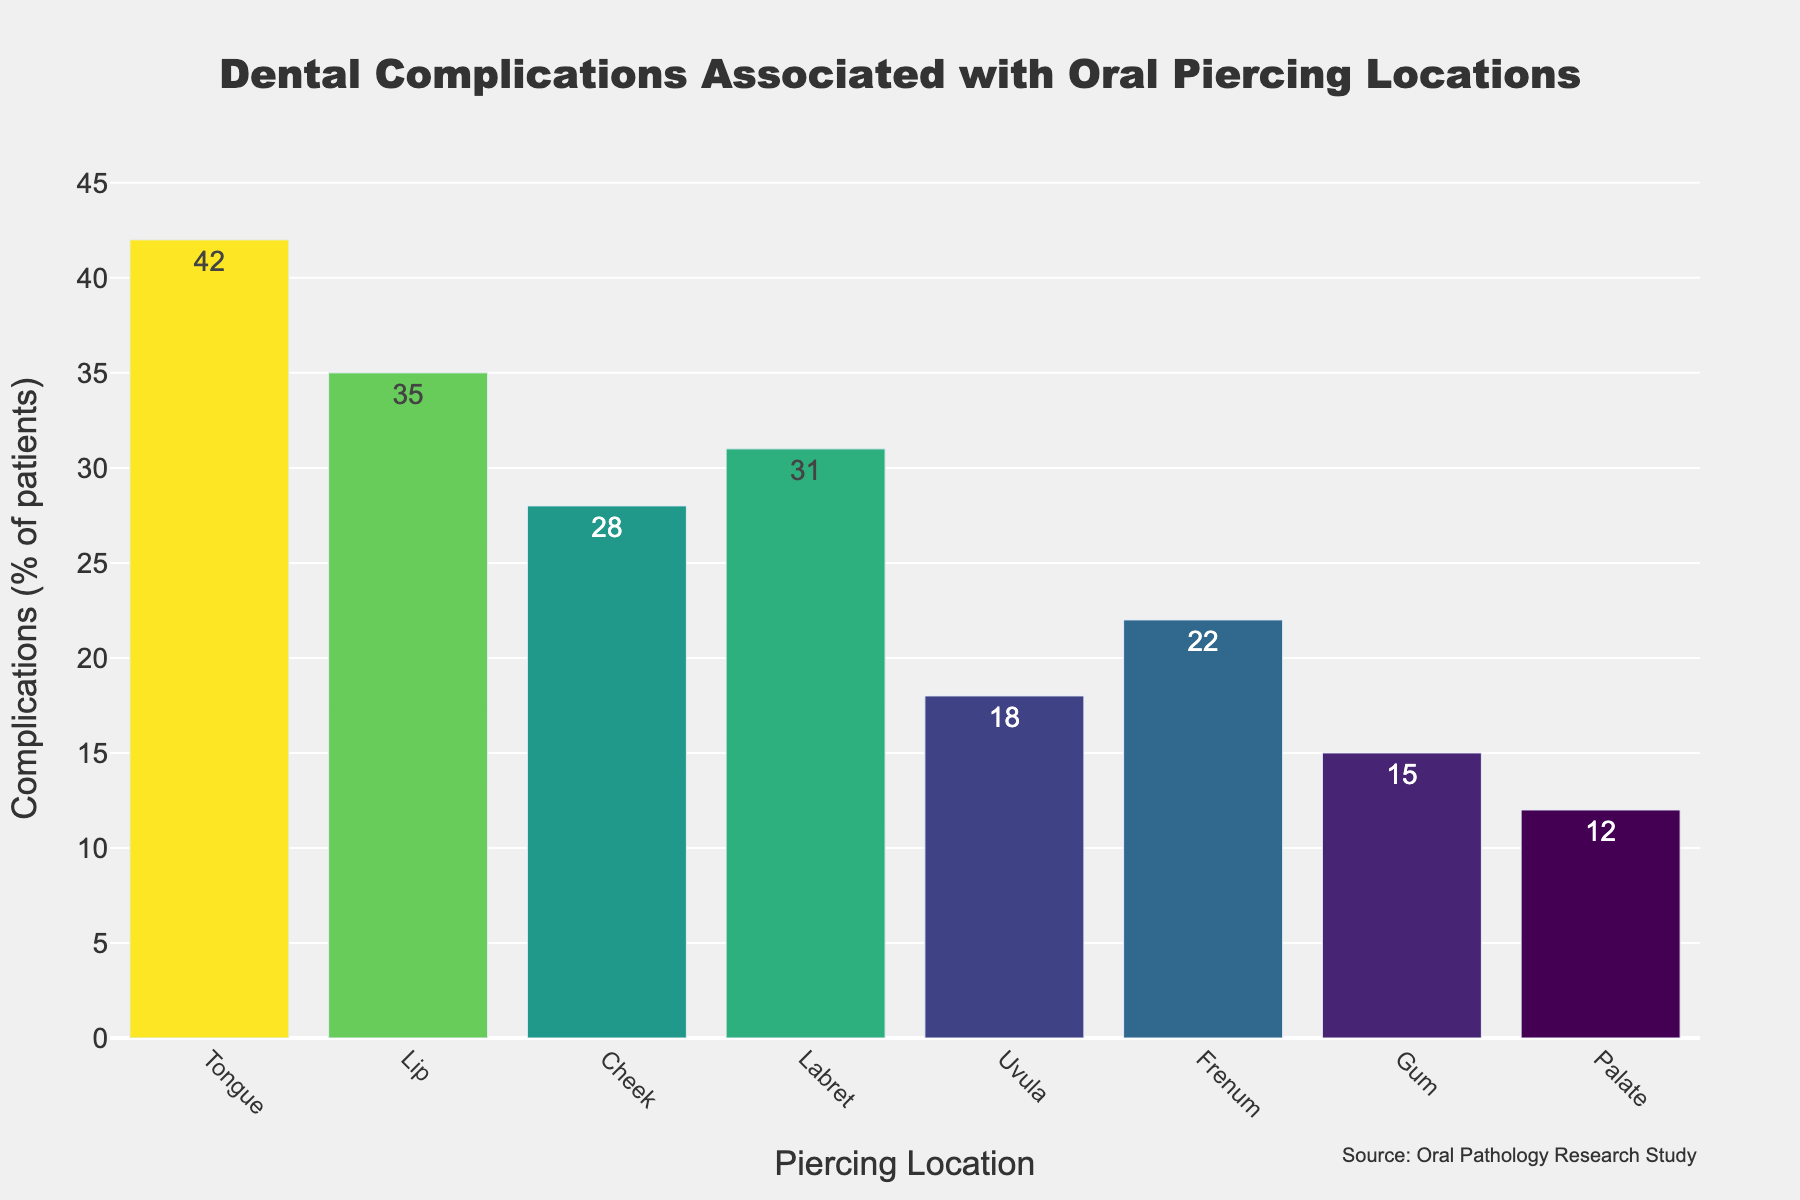Which piercing location has the highest rate of complications? By observing the heights of the bars, the Tongue piercing location has the highest bar, indicating it has the highest rate of complications.
Answer: Tongue Which piercing location has the lowest rate of complications? By looking at the shortest bar, the Palate piercing location has the lowest rate of complications.
Answer: Palate How much higher is the complication rate for Tongue piercings compared to Palate piercings? The Tongue complication rate is 42%, and the Palate complication rate is 12%, so 42% - 12% = 30%. The Tongue complication rate is 30% higher than the Palate complication rate.
Answer: 30% What is the average complication rate for all piercing locations shown? Add all the complication rates and divide by the number of locations: (42 + 35 + 28 + 31 + 18 + 22 + 15 + 12) / 8 = 203 / 8 = 25.375%.
Answer: 25.375% Which piercing location has a complication rate closest to the average complication rate? The average rate is 25.375%. The comparison rates are: Tongue 42% (+16.625), Lip 35% (+9.625), Cheek 28% (+2.625), Labret 31% (-5.625), Uvula 18% (-7.375), Frenum 22% (-3.375), Gum 15% (-10.375), Palate 12% (-13.375). The closest is Cheek with 28%.
Answer: Cheek Which piercing locations have complication rates below 20%? By observing bars shorter than the 20% mark: Uvula 18%, Gum 15%, Palate 12% are below 20%.
Answer: Uvula, Gum, Palate Are there more piercing locations with complication rates above or below 25%? Locations above 25%: Tongue, Lip, Cheek, Labret. Locations below 25%: Uvula, Frenum, Gum, Palate. There are 4 locations for both above and below.
Answer: Equal (4 each) By how much does the complication rate for Lip piercings exceed the complication rate for Frenum piercings? The Lip complication rate is 35% and the Frenum complication rate is 22%, so 35% - 22% = 13%. The Lip complication rate exceeds the Frenum complication rate by 13%.
Answer: 13% Which piercing location has a complication rate that is closest to but not exceeding 30%? The complication rates around 30% are Cheek 28% and Labret 31%. The closest not exceeding 30% is Cheek with 28%.
Answer: Cheek 